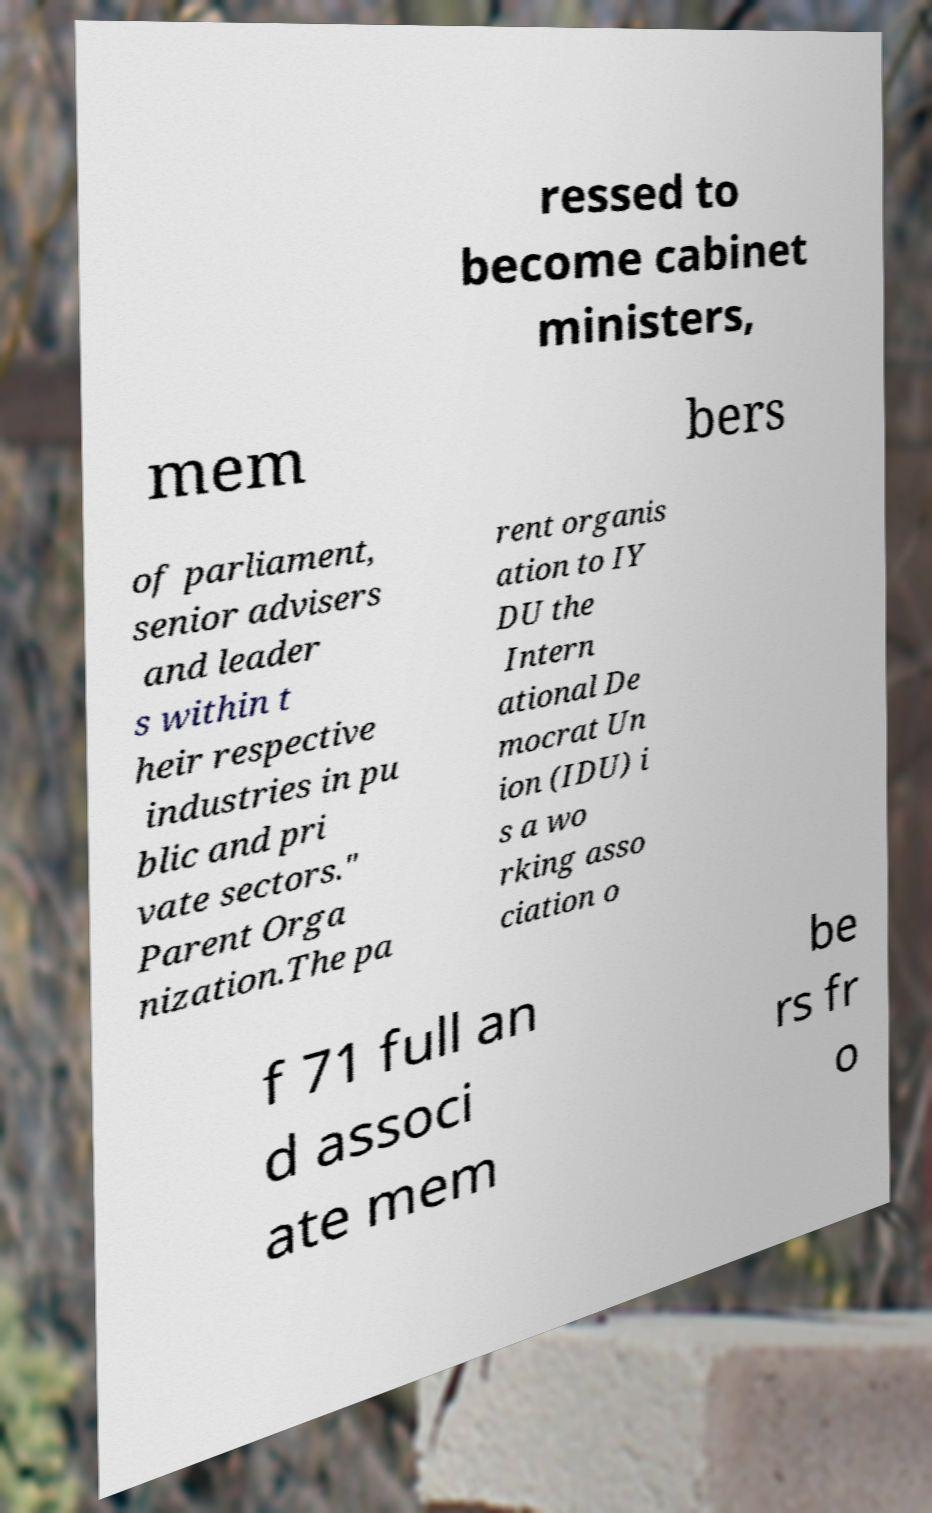Could you assist in decoding the text presented in this image and type it out clearly? ressed to become cabinet ministers, mem bers of parliament, senior advisers and leader s within t heir respective industries in pu blic and pri vate sectors." Parent Orga nization.The pa rent organis ation to IY DU the Intern ational De mocrat Un ion (IDU) i s a wo rking asso ciation o f 71 full an d associ ate mem be rs fr o 